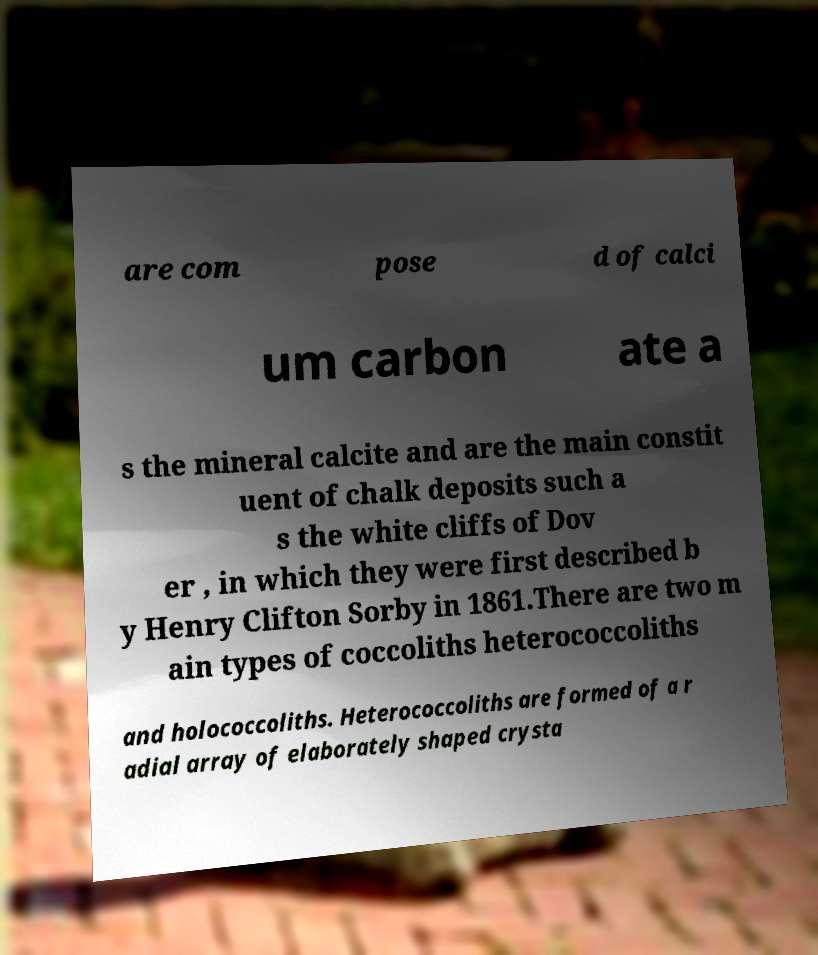Can you read and provide the text displayed in the image?This photo seems to have some interesting text. Can you extract and type it out for me? are com pose d of calci um carbon ate a s the mineral calcite and are the main constit uent of chalk deposits such a s the white cliffs of Dov er , in which they were first described b y Henry Clifton Sorby in 1861.There are two m ain types of coccoliths heterococcoliths and holococcoliths. Heterococcoliths are formed of a r adial array of elaborately shaped crysta 